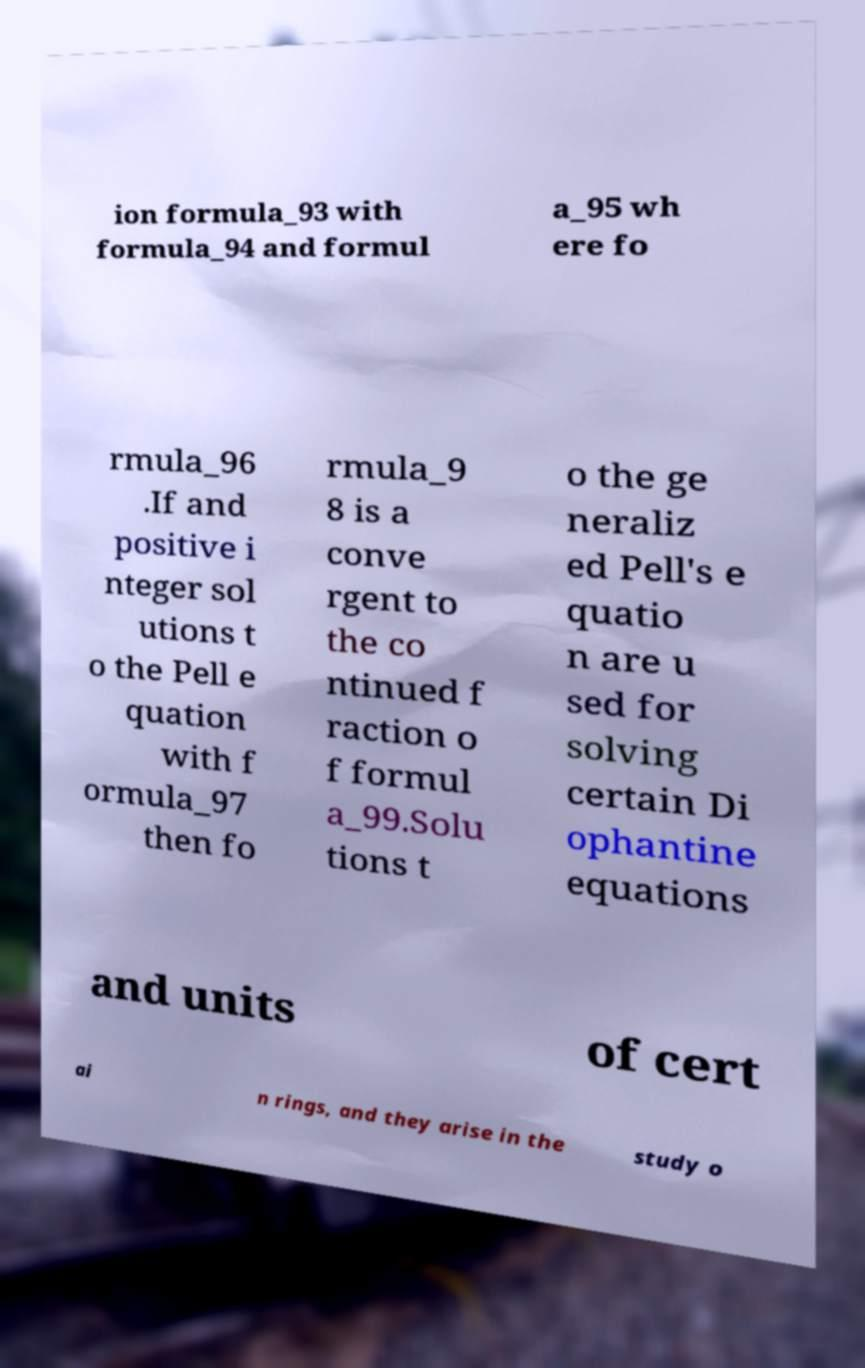There's text embedded in this image that I need extracted. Can you transcribe it verbatim? ion formula_93 with formula_94 and formul a_95 wh ere fo rmula_96 .If and positive i nteger sol utions t o the Pell e quation with f ormula_97 then fo rmula_9 8 is a conve rgent to the co ntinued f raction o f formul a_99.Solu tions t o the ge neraliz ed Pell's e quatio n are u sed for solving certain Di ophantine equations and units of cert ai n rings, and they arise in the study o 